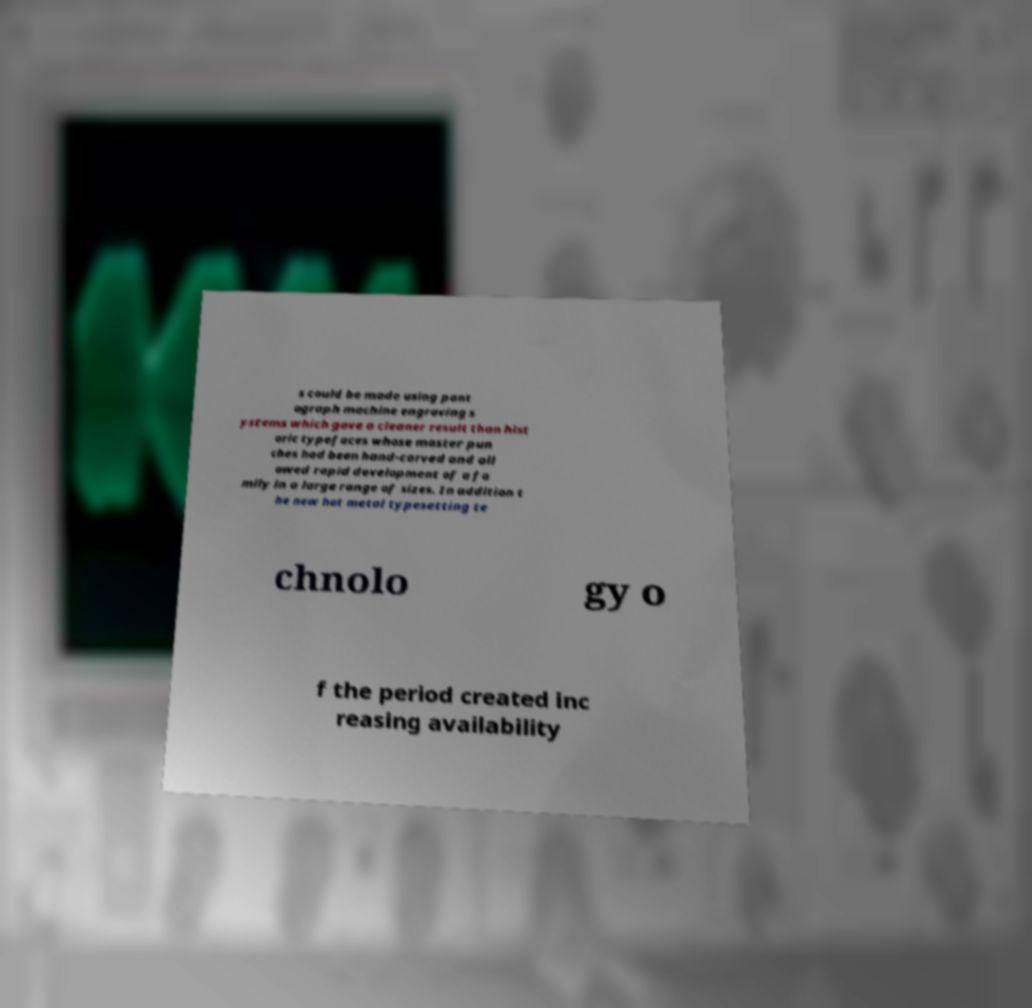For documentation purposes, I need the text within this image transcribed. Could you provide that? s could be made using pant ograph machine engraving s ystems which gave a cleaner result than hist oric typefaces whose master pun ches had been hand-carved and all owed rapid development of a fa mily in a large range of sizes. In addition t he new hot metal typesetting te chnolo gy o f the period created inc reasing availability 